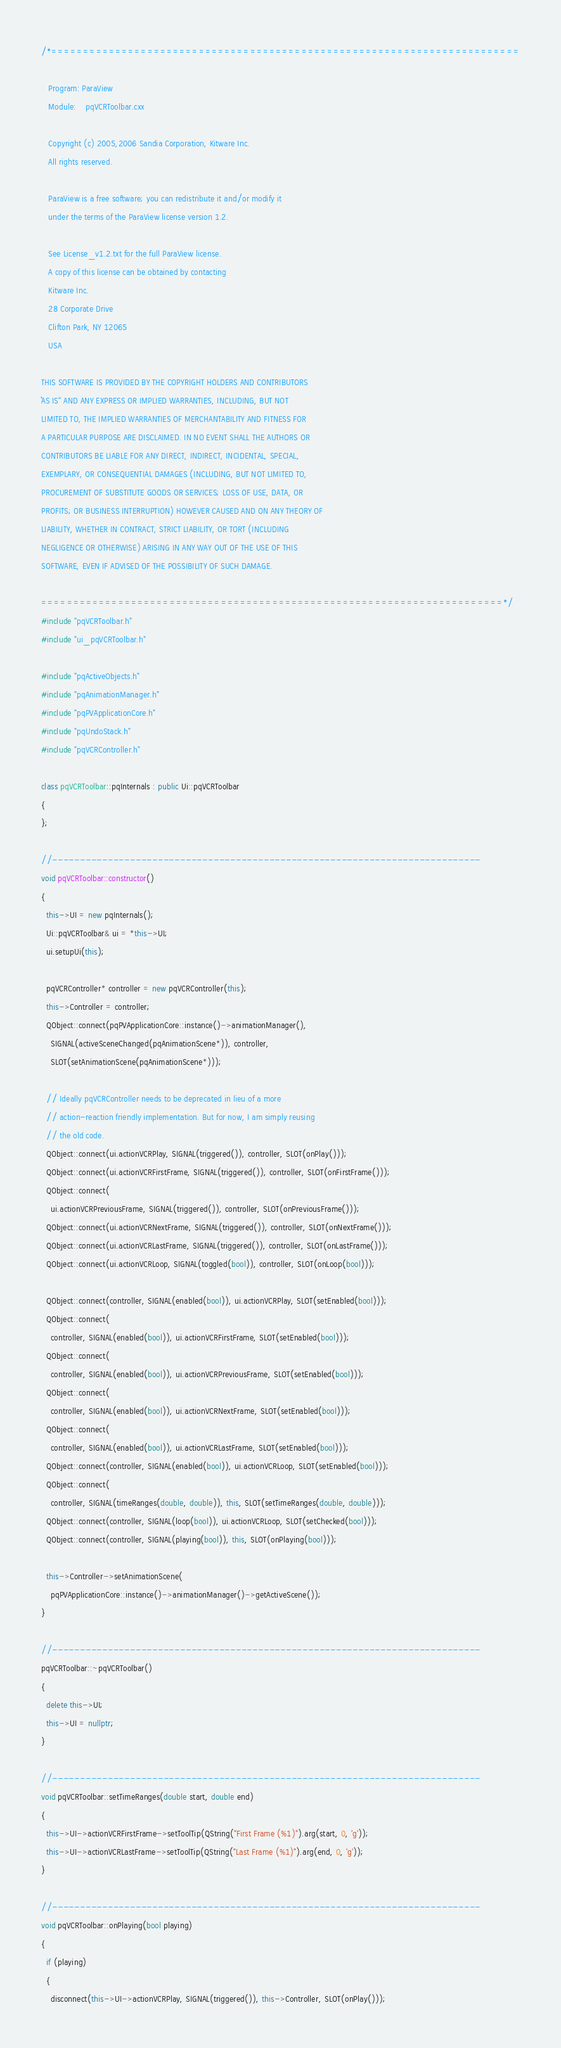Convert code to text. <code><loc_0><loc_0><loc_500><loc_500><_C++_>/*=========================================================================

   Program: ParaView
   Module:    pqVCRToolbar.cxx

   Copyright (c) 2005,2006 Sandia Corporation, Kitware Inc.
   All rights reserved.

   ParaView is a free software; you can redistribute it and/or modify it
   under the terms of the ParaView license version 1.2.

   See License_v1.2.txt for the full ParaView license.
   A copy of this license can be obtained by contacting
   Kitware Inc.
   28 Corporate Drive
   Clifton Park, NY 12065
   USA

THIS SOFTWARE IS PROVIDED BY THE COPYRIGHT HOLDERS AND CONTRIBUTORS
``AS IS'' AND ANY EXPRESS OR IMPLIED WARRANTIES, INCLUDING, BUT NOT
LIMITED TO, THE IMPLIED WARRANTIES OF MERCHANTABILITY AND FITNESS FOR
A PARTICULAR PURPOSE ARE DISCLAIMED. IN NO EVENT SHALL THE AUTHORS OR
CONTRIBUTORS BE LIABLE FOR ANY DIRECT, INDIRECT, INCIDENTAL, SPECIAL,
EXEMPLARY, OR CONSEQUENTIAL DAMAGES (INCLUDING, BUT NOT LIMITED TO,
PROCUREMENT OF SUBSTITUTE GOODS OR SERVICES; LOSS OF USE, DATA, OR
PROFITS; OR BUSINESS INTERRUPTION) HOWEVER CAUSED AND ON ANY THEORY OF
LIABILITY, WHETHER IN CONTRACT, STRICT LIABILITY, OR TORT (INCLUDING
NEGLIGENCE OR OTHERWISE) ARISING IN ANY WAY OUT OF THE USE OF THIS
SOFTWARE, EVEN IF ADVISED OF THE POSSIBILITY OF SUCH DAMAGE.

========================================================================*/
#include "pqVCRToolbar.h"
#include "ui_pqVCRToolbar.h"

#include "pqActiveObjects.h"
#include "pqAnimationManager.h"
#include "pqPVApplicationCore.h"
#include "pqUndoStack.h"
#include "pqVCRController.h"

class pqVCRToolbar::pqInternals : public Ui::pqVCRToolbar
{
};

//-----------------------------------------------------------------------------
void pqVCRToolbar::constructor()
{
  this->UI = new pqInternals();
  Ui::pqVCRToolbar& ui = *this->UI;
  ui.setupUi(this);

  pqVCRController* controller = new pqVCRController(this);
  this->Controller = controller;
  QObject::connect(pqPVApplicationCore::instance()->animationManager(),
    SIGNAL(activeSceneChanged(pqAnimationScene*)), controller,
    SLOT(setAnimationScene(pqAnimationScene*)));

  // Ideally pqVCRController needs to be deprecated in lieu of a more
  // action-reaction friendly implementation. But for now, I am simply reusing
  // the old code.
  QObject::connect(ui.actionVCRPlay, SIGNAL(triggered()), controller, SLOT(onPlay()));
  QObject::connect(ui.actionVCRFirstFrame, SIGNAL(triggered()), controller, SLOT(onFirstFrame()));
  QObject::connect(
    ui.actionVCRPreviousFrame, SIGNAL(triggered()), controller, SLOT(onPreviousFrame()));
  QObject::connect(ui.actionVCRNextFrame, SIGNAL(triggered()), controller, SLOT(onNextFrame()));
  QObject::connect(ui.actionVCRLastFrame, SIGNAL(triggered()), controller, SLOT(onLastFrame()));
  QObject::connect(ui.actionVCRLoop, SIGNAL(toggled(bool)), controller, SLOT(onLoop(bool)));

  QObject::connect(controller, SIGNAL(enabled(bool)), ui.actionVCRPlay, SLOT(setEnabled(bool)));
  QObject::connect(
    controller, SIGNAL(enabled(bool)), ui.actionVCRFirstFrame, SLOT(setEnabled(bool)));
  QObject::connect(
    controller, SIGNAL(enabled(bool)), ui.actionVCRPreviousFrame, SLOT(setEnabled(bool)));
  QObject::connect(
    controller, SIGNAL(enabled(bool)), ui.actionVCRNextFrame, SLOT(setEnabled(bool)));
  QObject::connect(
    controller, SIGNAL(enabled(bool)), ui.actionVCRLastFrame, SLOT(setEnabled(bool)));
  QObject::connect(controller, SIGNAL(enabled(bool)), ui.actionVCRLoop, SLOT(setEnabled(bool)));
  QObject::connect(
    controller, SIGNAL(timeRanges(double, double)), this, SLOT(setTimeRanges(double, double)));
  QObject::connect(controller, SIGNAL(loop(bool)), ui.actionVCRLoop, SLOT(setChecked(bool)));
  QObject::connect(controller, SIGNAL(playing(bool)), this, SLOT(onPlaying(bool)));

  this->Controller->setAnimationScene(
    pqPVApplicationCore::instance()->animationManager()->getActiveScene());
}

//-----------------------------------------------------------------------------
pqVCRToolbar::~pqVCRToolbar()
{
  delete this->UI;
  this->UI = nullptr;
}

//-----------------------------------------------------------------------------
void pqVCRToolbar::setTimeRanges(double start, double end)
{
  this->UI->actionVCRFirstFrame->setToolTip(QString("First Frame (%1)").arg(start, 0, 'g'));
  this->UI->actionVCRLastFrame->setToolTip(QString("Last Frame (%1)").arg(end, 0, 'g'));
}

//-----------------------------------------------------------------------------
void pqVCRToolbar::onPlaying(bool playing)
{
  if (playing)
  {
    disconnect(this->UI->actionVCRPlay, SIGNAL(triggered()), this->Controller, SLOT(onPlay()));</code> 